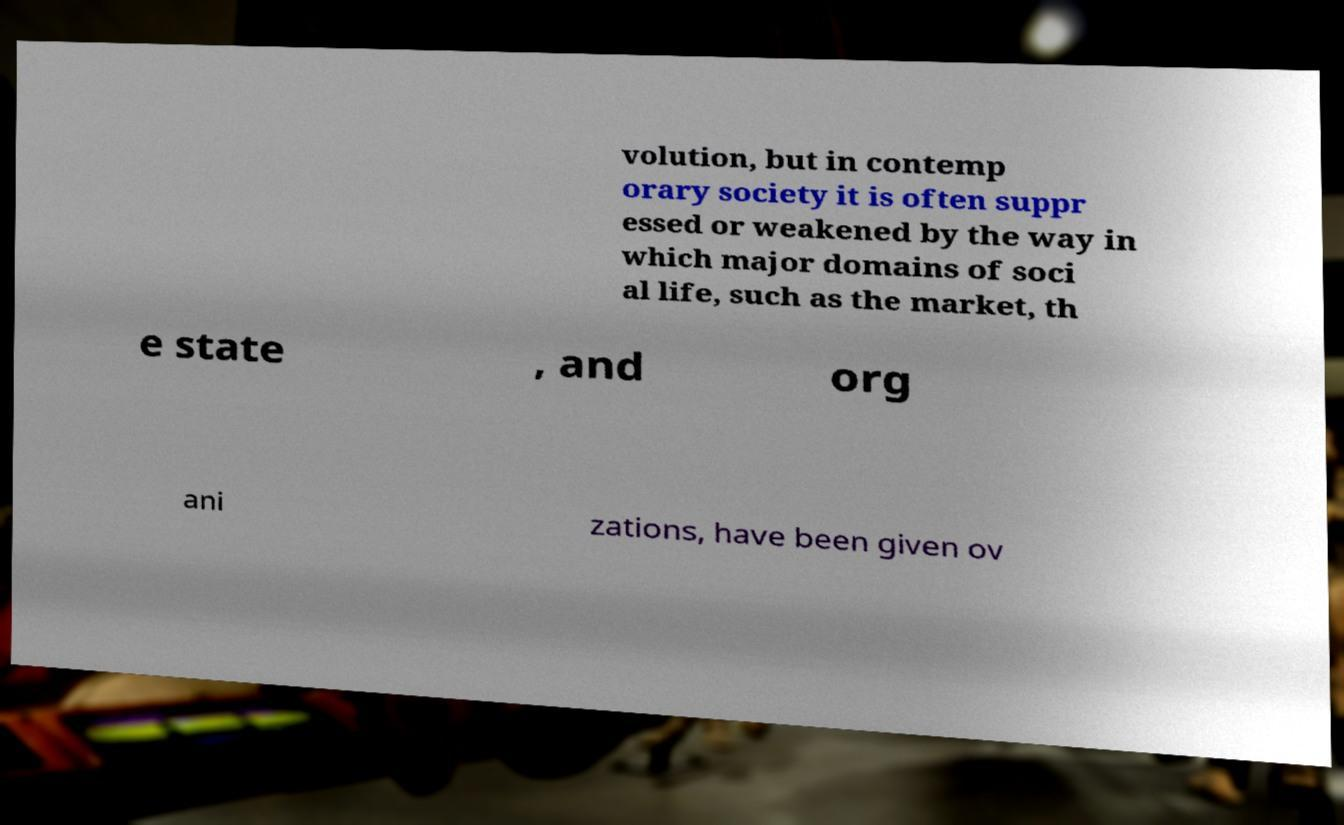There's text embedded in this image that I need extracted. Can you transcribe it verbatim? volution, but in contemp orary society it is often suppr essed or weakened by the way in which major domains of soci al life, such as the market, th e state , and org ani zations, have been given ov 